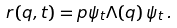<formula> <loc_0><loc_0><loc_500><loc_500>r ( q , t ) = p { \psi _ { t } } { \Lambda ( q ) \, \psi _ { t } } \, .</formula> 